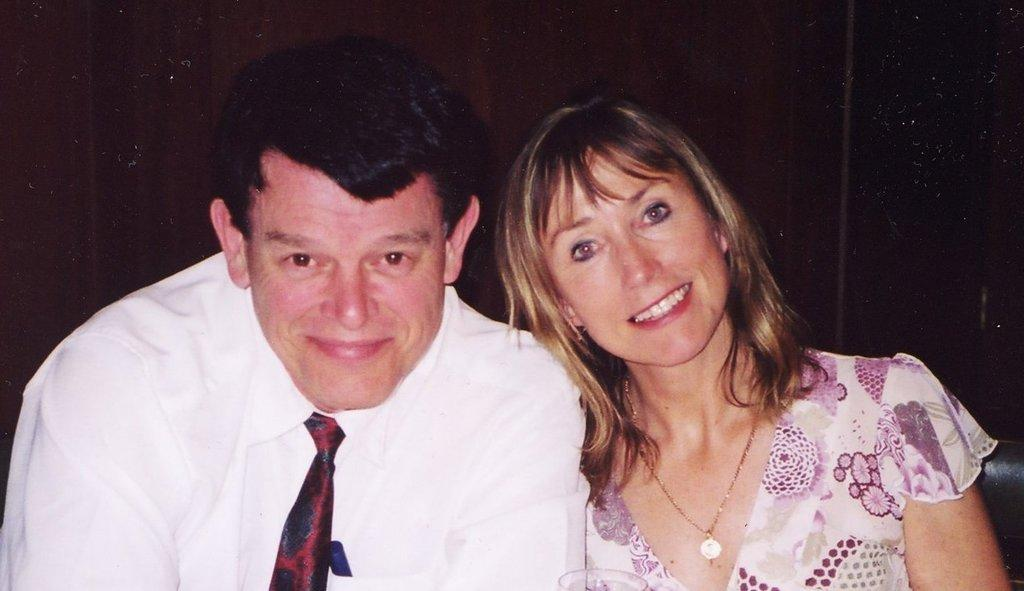What is the color of the background in the image? The background of the image is dark. What are the people in the image doing? The man and the woman are sitting on a couch. How do the man and the woman appear to feel in the image? Both the man and the woman have smiling faces, suggesting they are happy or enjoying themselves. What type of pies can be seen in the image? There are no pies present in the image. 